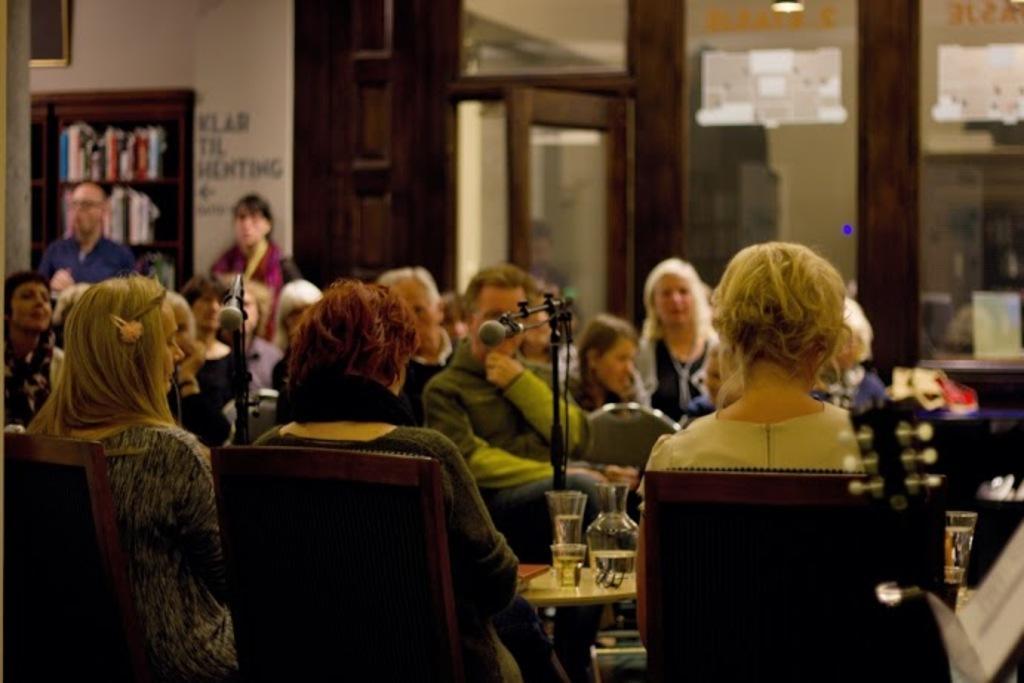Can you describe this image briefly? This picture shows the inner view of a building. There are some people sitting on the chairs, some objects are on the table, one light attached to the ceiling, some people are standing, one door, one frame attached to the wall, two microphone stands with two microphones, some objects are on the surface, some books are in the wooden cupboard, one musical instrument, some text on the wall, some posters attached to the glass and some text on the glass wall. 